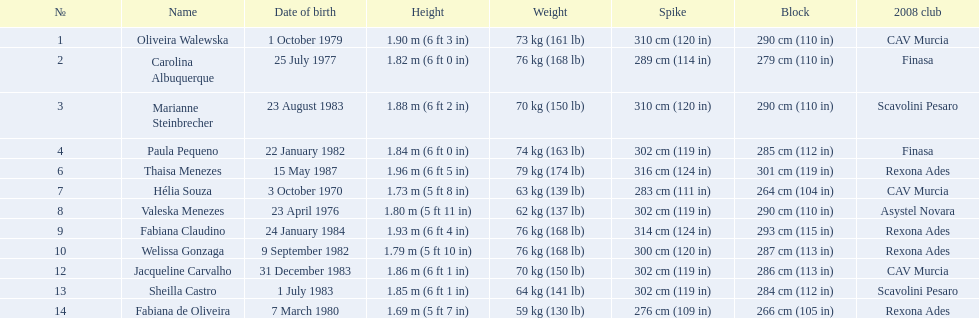What is the height of each player? 1.90 m (6 ft 3 in), 1.82 m (6 ft 0 in), 1.88 m (6 ft 2 in), 1.84 m (6 ft 0 in), 1.96 m (6 ft 5 in), 1.73 m (5 ft 8 in), 1.80 m (5 ft 11 in), 1.93 m (6 ft 4 in), 1.79 m (5 ft 10 in), 1.86 m (6 ft 1 in), 1.85 m (6 ft 1 in), 1.69 m (5 ft 7 in). Which one has the smallest height? 1.69 m (5 ft 7 in). Who is the 5'7 tall player? Fabiana de Oliveira. 